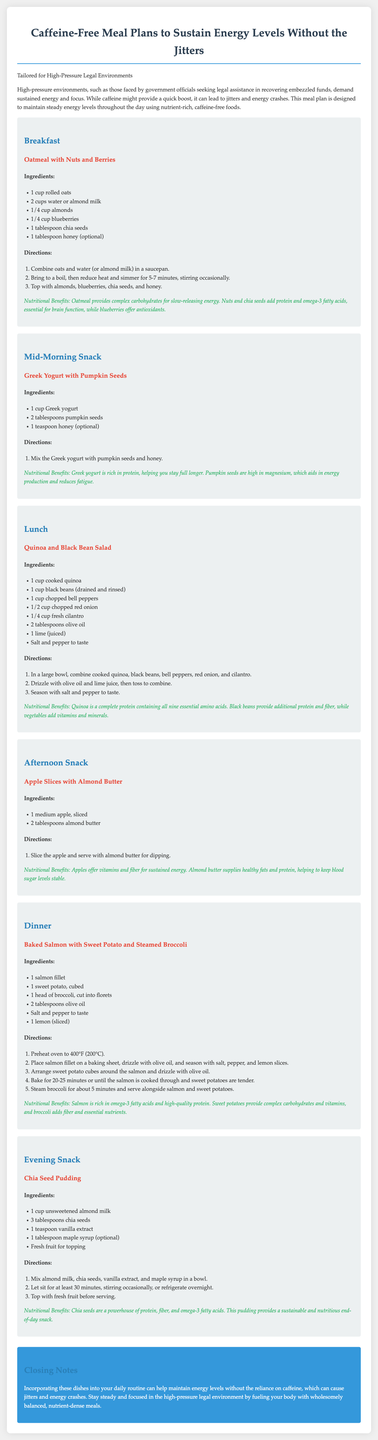What is the title of the meal plan? The title of the meal plan is found in the document header.
Answer: Caffeine-Free Meal Plans to Sustain Energy Levels Without the Jitters What is one ingredient in the breakfast oatmeal? The breakfast oatmeal includes several ingredients listed under the breakfast section.
Answer: Almonds What is the main protein source in the lunch recipe? The lunch recipe lists ingredients, and one of them is a significant protein source.
Answer: Quinoa How many cups of water or almond milk are needed for the breakfast oatmeal? The quantity of liquid required for the oatmeal is specified in the ingredients list.
Answer: 2 cups What is a benefit of the afternoon snack? The benefits are described below each meal section.
Answer: Sustained energy Which meal includes pumpkin seeds? The snack section explicitly mentions the ingredients used in that meal.
Answer: Mid-Morning Snack What is the cooking temperature for the dinner salmon? The cooking temperature is provided near the top of the dinner recipe.
Answer: 400°F What type of milk is used in the chia seed pudding? The type of milk is explicitly mentioned in the pudding recipe.
Answer: Unsweetened almond milk What is listed as optional in the breakfast recipe? The optional item is mentioned in the ingredients list for the breakfast.
Answer: Honey 